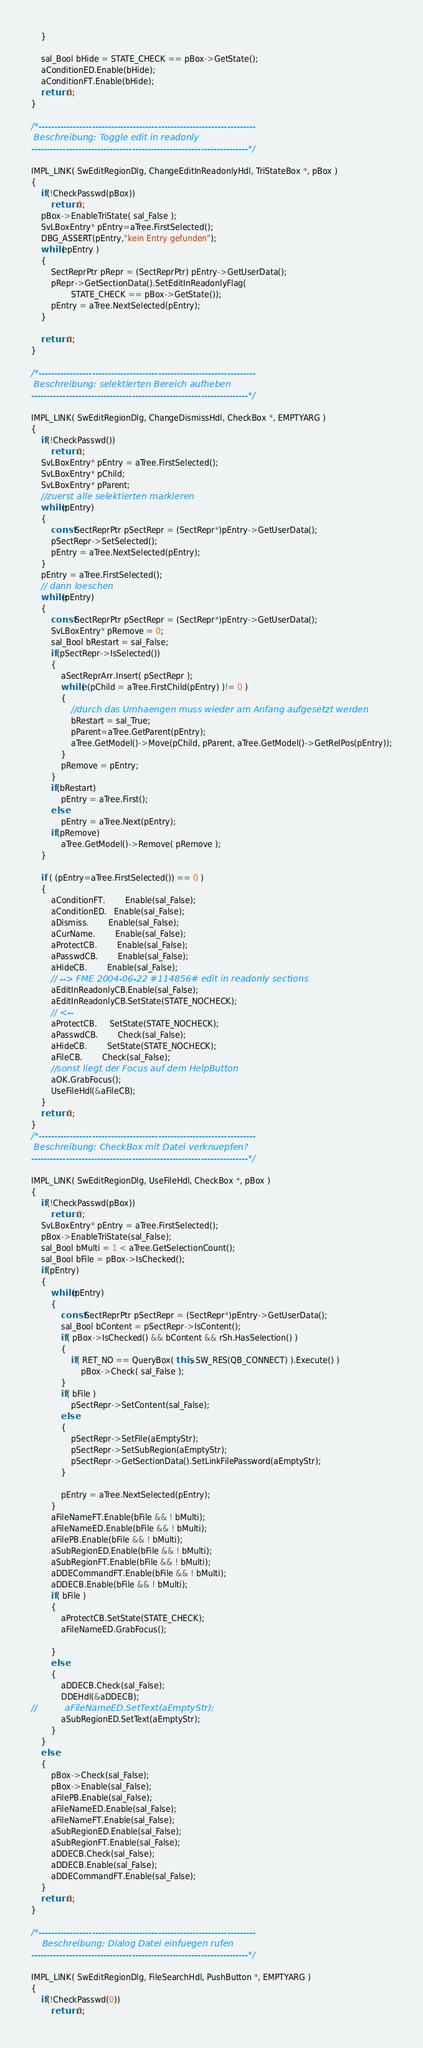<code> <loc_0><loc_0><loc_500><loc_500><_C++_>	}

	sal_Bool bHide = STATE_CHECK == pBox->GetState();
    aConditionED.Enable(bHide);
    aConditionFT.Enable(bHide);
    return 0;
}

/*---------------------------------------------------------------------
 Beschreibung: Toggle edit in readonly
---------------------------------------------------------------------*/

IMPL_LINK( SwEditRegionDlg, ChangeEditInReadonlyHdl, TriStateBox *, pBox )
{
    if(!CheckPasswd(pBox))
        return 0;
    pBox->EnableTriState( sal_False );
    SvLBoxEntry* pEntry=aTree.FirstSelected();
    DBG_ASSERT(pEntry,"kein Entry gefunden");
    while( pEntry )
    {
        SectReprPtr pRepr = (SectReprPtr) pEntry->GetUserData();
        pRepr->GetSectionData().SetEditInReadonlyFlag(
                STATE_CHECK == pBox->GetState());
        pEntry = aTree.NextSelected(pEntry);
    }

    return 0;
}

/*---------------------------------------------------------------------
 Beschreibung: selektierten Bereich aufheben
---------------------------------------------------------------------*/

IMPL_LINK( SwEditRegionDlg, ChangeDismissHdl, CheckBox *, EMPTYARG )
{
    if(!CheckPasswd())
        return 0;
    SvLBoxEntry* pEntry = aTree.FirstSelected();
	SvLBoxEntry* pChild;
	SvLBoxEntry* pParent;
	//zuerst alle selektierten markieren
	while(pEntry)
	{
		const SectReprPtr pSectRepr = (SectRepr*)pEntry->GetUserData();
		pSectRepr->SetSelected();
		pEntry = aTree.NextSelected(pEntry);
	}
	pEntry = aTree.FirstSelected();
	// dann loeschen
	while(pEntry)
	{
		const SectReprPtr pSectRepr = (SectRepr*)pEntry->GetUserData();
		SvLBoxEntry* pRemove = 0;
		sal_Bool bRestart = sal_False;
		if(pSectRepr->IsSelected())
		{
			aSectReprArr.Insert( pSectRepr );
			while( (pChild = aTree.FirstChild(pEntry) )!= 0 )
			{
				//durch das Umhaengen muss wieder am Anfang aufgesetzt werden
				bRestart = sal_True;
				pParent=aTree.GetParent(pEntry);
				aTree.GetModel()->Move(pChild, pParent, aTree.GetModel()->GetRelPos(pEntry));
			}
			pRemove = pEntry;
		}
		if(bRestart)
			pEntry = aTree.First();
		else
			pEntry = aTree.Next(pEntry);
		if(pRemove)
			aTree.GetModel()->Remove( pRemove );
	}

	if ( (pEntry=aTree.FirstSelected()) == 0 )
	{
        aConditionFT.        Enable(sal_False);
        aConditionED.   Enable(sal_False);
		aDismiss.		Enable(sal_False);
		aCurName.		Enable(sal_False);
		aProtectCB.		Enable(sal_False);
		aPasswdCB.		Enable(sal_False);
		aHideCB.		Enable(sal_False);
        // --> FME 2004-06-22 #114856# edit in readonly sections
        aEditInReadonlyCB.Enable(sal_False);
        aEditInReadonlyCB.SetState(STATE_NOCHECK);
        // <--
        aProtectCB.     SetState(STATE_NOCHECK);
		aPasswdCB.		Check(sal_False);
		aHideCB.		SetState(STATE_NOCHECK);
		aFileCB.		Check(sal_False);
		//sonst liegt der Focus auf dem HelpButton
		aOK.GrabFocus();
		UseFileHdl(&aFileCB);
	}
	return 0;
}
/*---------------------------------------------------------------------
 Beschreibung: CheckBox mit Datei verknuepfen?
---------------------------------------------------------------------*/

IMPL_LINK( SwEditRegionDlg, UseFileHdl, CheckBox *, pBox )
{
    if(!CheckPasswd(pBox))
        return 0;
    SvLBoxEntry* pEntry = aTree.FirstSelected();
	pBox->EnableTriState(sal_False);
	sal_Bool bMulti = 1 < aTree.GetSelectionCount();
	sal_Bool bFile = pBox->IsChecked();
	if(pEntry)
	{
		while(pEntry)
		{
			const SectReprPtr pSectRepr = (SectRepr*)pEntry->GetUserData();
			sal_Bool bContent = pSectRepr->IsContent();
			if( pBox->IsChecked() && bContent && rSh.HasSelection() )
			{
				if( RET_NO == QueryBox( this, SW_RES(QB_CONNECT) ).Execute() )
					pBox->Check( sal_False );
			}
			if( bFile )
				pSectRepr->SetContent(sal_False);
			else
			{
				pSectRepr->SetFile(aEmptyStr);
				pSectRepr->SetSubRegion(aEmptyStr);
                pSectRepr->GetSectionData().SetLinkFilePassword(aEmptyStr);
			}

			pEntry = aTree.NextSelected(pEntry);
		}
		aFileNameFT.Enable(bFile && ! bMulti);
		aFileNameED.Enable(bFile && ! bMulti);
		aFilePB.Enable(bFile && ! bMulti);
		aSubRegionED.Enable(bFile && ! bMulti);
		aSubRegionFT.Enable(bFile && ! bMulti);
		aDDECommandFT.Enable(bFile && ! bMulti);
		aDDECB.Enable(bFile && ! bMulti);
		if( bFile )
		{
			aProtectCB.SetState(STATE_CHECK);
			aFileNameED.GrabFocus();

		}
		else
		{
			aDDECB.Check(sal_False);
			DDEHdl(&aDDECB);
//			aFileNameED.SetText(aEmptyStr);
			aSubRegionED.SetText(aEmptyStr);
		}
	}
	else
	{
		pBox->Check(sal_False);
		pBox->Enable(sal_False);
		aFilePB.Enable(sal_False);
		aFileNameED.Enable(sal_False);
		aFileNameFT.Enable(sal_False);
		aSubRegionED.Enable(sal_False);
		aSubRegionFT.Enable(sal_False);
		aDDECB.Check(sal_False);
		aDDECB.Enable(sal_False);
		aDDECommandFT.Enable(sal_False);
	}
	return 0;
}

/*---------------------------------------------------------------------
	Beschreibung: Dialog Datei einfuegen rufen
---------------------------------------------------------------------*/

IMPL_LINK( SwEditRegionDlg, FileSearchHdl, PushButton *, EMPTYARG )
{
    if(!CheckPasswd(0))
        return 0;
</code> 